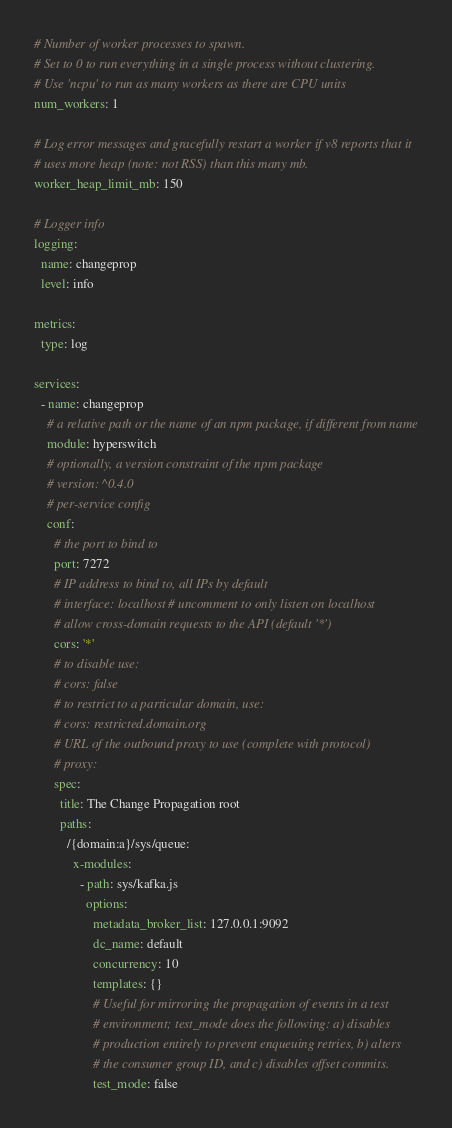<code> <loc_0><loc_0><loc_500><loc_500><_YAML_># Number of worker processes to spawn.
# Set to 0 to run everything in a single process without clustering.
# Use 'ncpu' to run as many workers as there are CPU units
num_workers: 1

# Log error messages and gracefully restart a worker if v8 reports that it
# uses more heap (note: not RSS) than this many mb.
worker_heap_limit_mb: 150

# Logger info
logging:
  name: changeprop
  level: info

metrics:
  type: log

services:
  - name: changeprop
    # a relative path or the name of an npm package, if different from name
    module: hyperswitch
    # optionally, a version constraint of the npm package
    # version: ^0.4.0
    # per-service config
    conf:
      # the port to bind to
      port: 7272
      # IP address to bind to, all IPs by default
      # interface: localhost # uncomment to only listen on localhost
      # allow cross-domain requests to the API (default '*')
      cors: '*'
      # to disable use:
      # cors: false
      # to restrict to a particular domain, use:
      # cors: restricted.domain.org
      # URL of the outbound proxy to use (complete with protocol)
      # proxy:
      spec:
        title: The Change Propagation root
        paths:
          /{domain:a}/sys/queue:
            x-modules:
              - path: sys/kafka.js
                options:
                  metadata_broker_list: 127.0.0.1:9092
                  dc_name: default
                  concurrency: 10
                  templates: {}
                  # Useful for mirroring the propagation of events in a test
                  # environment; test_mode does the following: a) disables
                  # production entirely to prevent enqueuing retries, b) alters
                  # the consumer group ID, and c) disables offset commits.
                  test_mode: false
</code> 